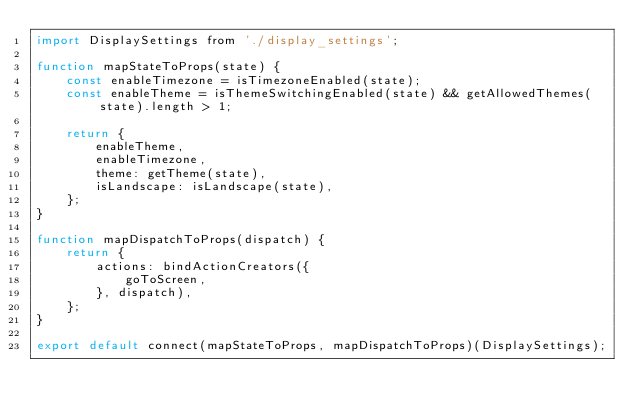Convert code to text. <code><loc_0><loc_0><loc_500><loc_500><_JavaScript_>import DisplaySettings from './display_settings';

function mapStateToProps(state) {
    const enableTimezone = isTimezoneEnabled(state);
    const enableTheme = isThemeSwitchingEnabled(state) && getAllowedThemes(state).length > 1;

    return {
        enableTheme,
        enableTimezone,
        theme: getTheme(state),
        isLandscape: isLandscape(state),
    };
}

function mapDispatchToProps(dispatch) {
    return {
        actions: bindActionCreators({
            goToScreen,
        }, dispatch),
    };
}

export default connect(mapStateToProps, mapDispatchToProps)(DisplaySettings);
</code> 